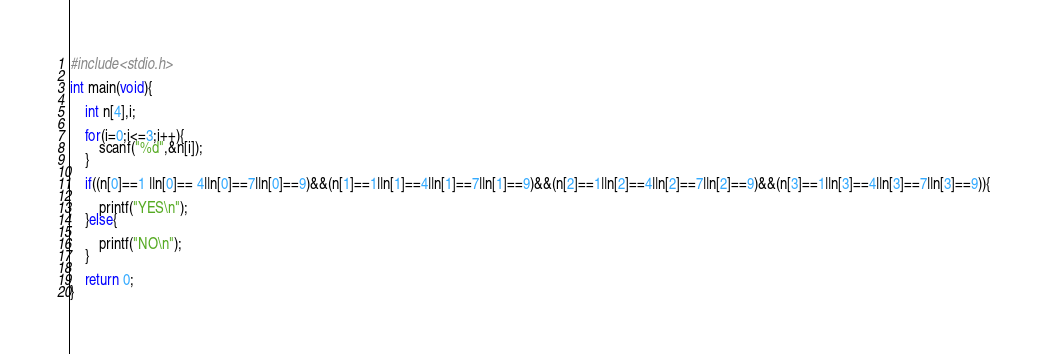<code> <loc_0><loc_0><loc_500><loc_500><_C_>#include<stdio.h>

int main(void){

	int n[4],i;

	for(i=0;i<=3;i++){
		scanf("%d",&n[i]);
	}

	if((n[0]==1 ||n[0]== 4||n[0]==7||n[0]==9)&&(n[1]==1||n[1]==4||n[1]==7||n[1]==9)&&(n[2]==1||n[2]==4||n[2]==7||n[2]==9)&&(n[3]==1||n[3]==4||n[3]==7||n[3]==9)){
	
		printf("YES\n");
	}else{
	
		printf("NO\n");
	}

	return 0;
}
</code> 